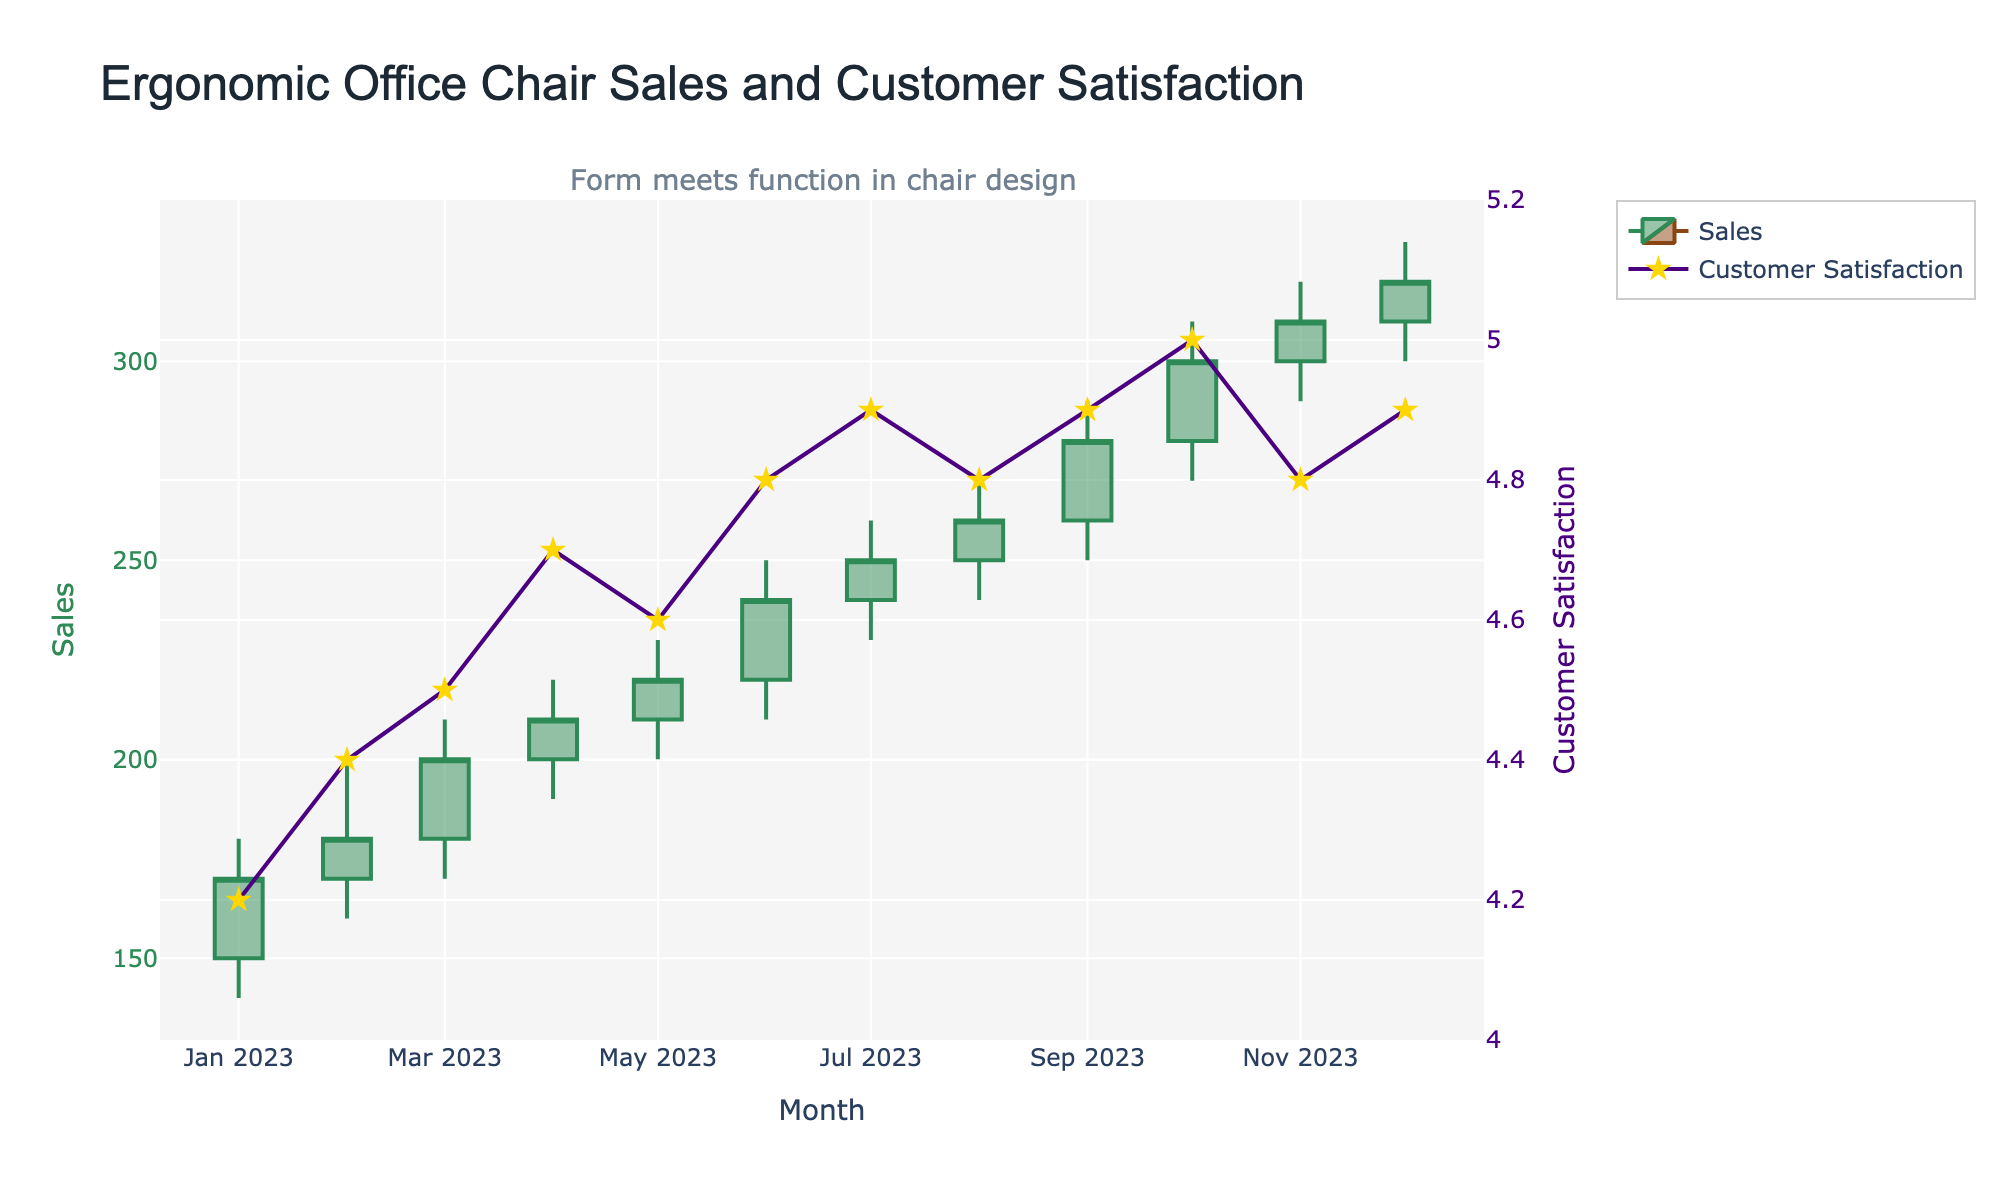what is the title of the plot? The title is often placed at the top of the plot and labeled for easy reference. In this case, it reads "Ergonomic Office Chair Sales and Customer Satisfaction."
Answer: Ergonomic Office Chair Sales and Customer Satisfaction How many months are displayed in the figure? The monthly data is available from January 2023 to December 2023. Counting these months gives a total of 12 months.
Answer: 12 What is the range of customer satisfaction scores shown on the secondary y-axis? The secondary y-axis ranges from 4.0 to 5.2, which is clear from the axis labels.
Answer: 4.0 to 5.2 In which month did customer satisfaction reach the highest score, and what was the score? The plot indicates customer satisfaction with a line graph. The highest score is at October 2023, marked as 5.0 on the y-axis.
Answer: October 2023, 5.0 Between which months did sales see the largest increase, and what was the difference? To find the largest sales increase, we need to examine the opening and closing sales between consecutive months. The largest increase is from June to July, with sales rising from an opening of 220 to a closing of 250. The difference is 250 - 220 = 30.
Answer: June to July, 30 Which month had the lowest recorded sales, and what was the value? The lowest recorded sales can be identified on the candlestick plot by locating the lowest 'Low' value. The lowest value is 140 in January.
Answer: January, 140 How did customer satisfaction change from May to June? The scatter line plot shows customer satisfaction values each month. From May to June, the customer satisfaction score increased from 4.6 to 4.8.
Answer: It increased by 0.2 What is the closing sales amount in December 2023? The closing sales amount for each month is marked by the candlestick's endpoint. For December, the closing sales are 320.
Answer: 320 Compare the sales trends and customer satisfaction trends over the year. Sales and customer satisfaction trends both show an increasing pattern over time. The sales show a steady rise from January's lowest values to December's highest. Similarly, customer satisfaction starts at 4.2 and peaks at 5.0 in October, then maintains high values. This suggests a correlation between improved customer satisfaction and increased sales.
Answer: Both increased Which months have the same average customer satisfaction score, and what is the score? By comparing the line graph points for customer satisfaction, August, November, and December all have an average satisfaction score of 4.8.
Answer: August, November, December, 4.8 